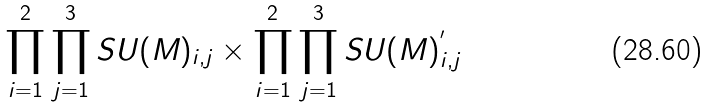Convert formula to latex. <formula><loc_0><loc_0><loc_500><loc_500>\prod _ { i = 1 } ^ { 2 } \prod _ { j = 1 } ^ { 3 } S U ( M ) _ { i , j } \times \prod _ { i = 1 } ^ { 2 } \prod _ { j = 1 } ^ { 3 } S U ( M ) ^ { ^ { \prime } } _ { i , j }</formula> 